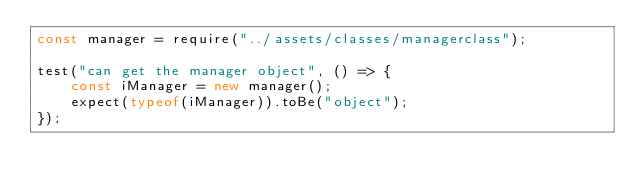<code> <loc_0><loc_0><loc_500><loc_500><_JavaScript_>const manager = require("../assets/classes/managerclass");

test("can get the manager object", () => {
    const iManager = new manager();
    expect(typeof(iManager)).toBe("object");
});</code> 